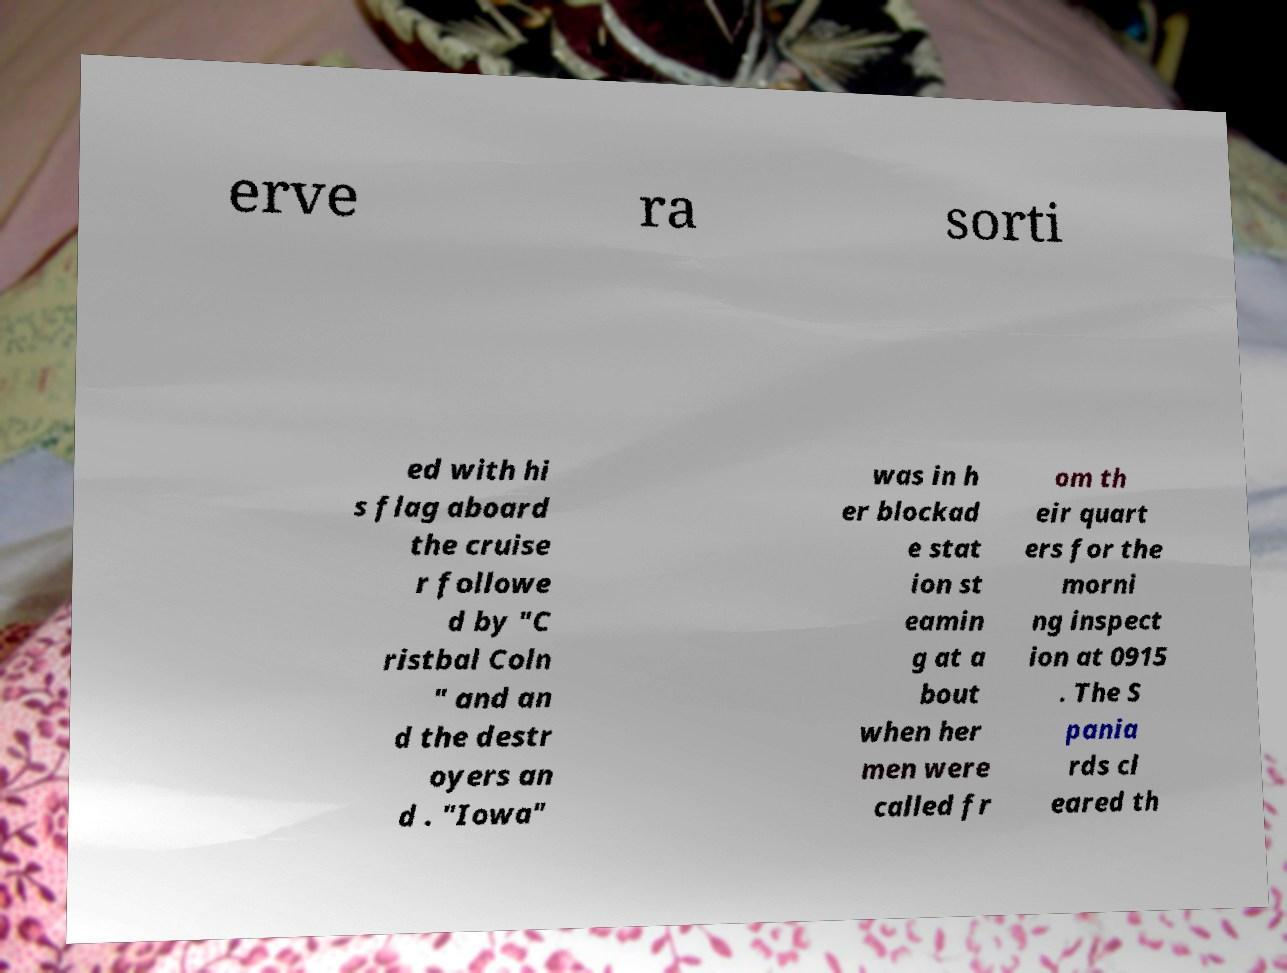Please identify and transcribe the text found in this image. erve ra sorti ed with hi s flag aboard the cruise r followe d by "C ristbal Coln " and an d the destr oyers an d . "Iowa" was in h er blockad e stat ion st eamin g at a bout when her men were called fr om th eir quart ers for the morni ng inspect ion at 0915 . The S pania rds cl eared th 